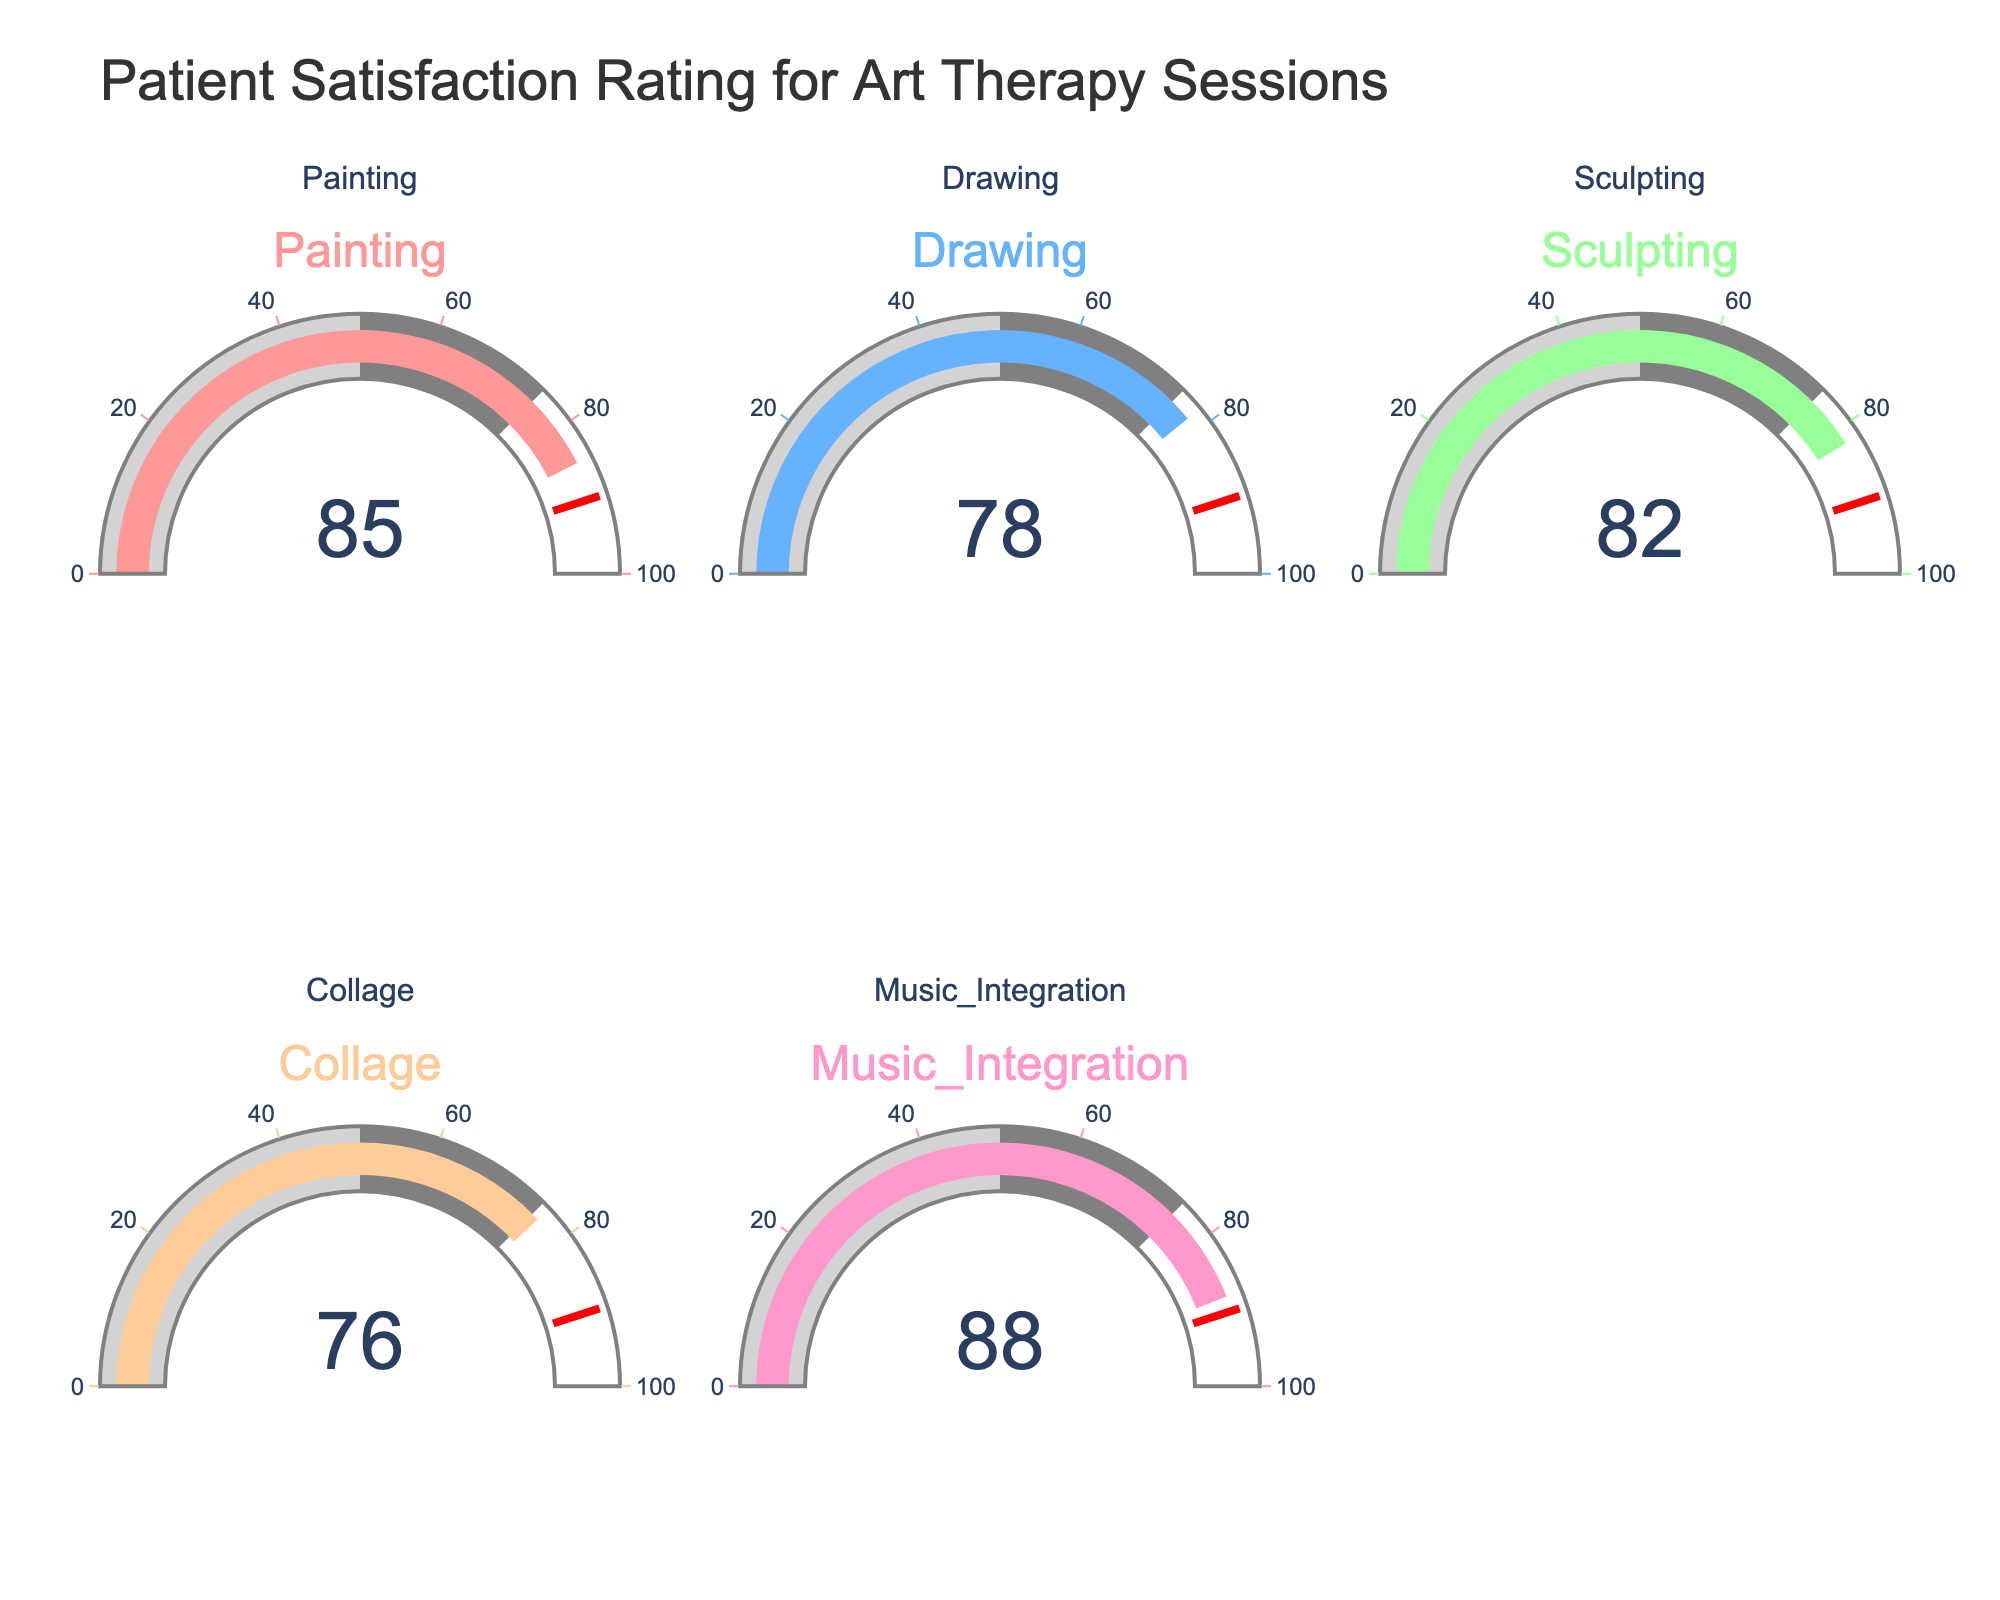What's the title of the figure? The title of the figure is displayed at the top of the plot. It reads "Patient Satisfaction Rating for Art Therapy Sessions."
Answer: Patient Satisfaction Rating for Art Therapy Sessions Which therapy session received the highest satisfaction rating? By looking at the gauges, the highest satisfaction rating is displayed on the gauge for Music Integration, which shows a value of 88.
Answer: Music Integration What is the satisfaction rating for Drawing therapy sessions? The gauge for Drawing shows a satisfaction rating value of 78. This is a straightforward observation from the gauge.
Answer: 78 What is the difference in satisfaction ratings between Painting and Collage sessions? The satisfaction rating for Painting is 85, and for Collage, it is 76. The difference can be calculated as 85 - 76 = 9.
Answer: 9 Which therapy session has the lowest satisfaction rating? From the visual representation, the lowest satisfaction rating is evident on the gauge for Collage, which shows a rating of 76.
Answer: Collage What is the average satisfaction rating across all therapy sessions? The ratings given are: Painting 85, Drawing 78, Sculpting 82, Collage 76, Music Integration 88. The average is calculated as (85 + 78 + 82 + 76 + 88) / 5 = 409 / 5 = 81.8.
Answer: 81.8 How many therapy sessions have a satisfaction rating above 80? The gauges show that Painting (85), Sculpting (82), and Music Integration (88) all have ratings above 80. This counts to three sessions.
Answer: 3 Is the satisfaction rating for Sculpting more than that for Drawing? The gauge for Sculpting shows a satisfaction rating of 82, while Drawing shows 78. Since 82 is greater than 78, Sculpting has a higher rating than Drawing.
Answer: Yes Which two therapy sessions have ratings closest to each other? The ratings for Drawing and Collage are 78 and 76, respectively. Their difference is 2, which is the smallest difference between ratings of any two sessions.
Answer: Drawing and Collage Is there any therapy session with a satisfaction rating at or above 90? None of the gauges shows a satisfaction rating of 90 or higher. The highest is Music Integration at 88.
Answer: No 